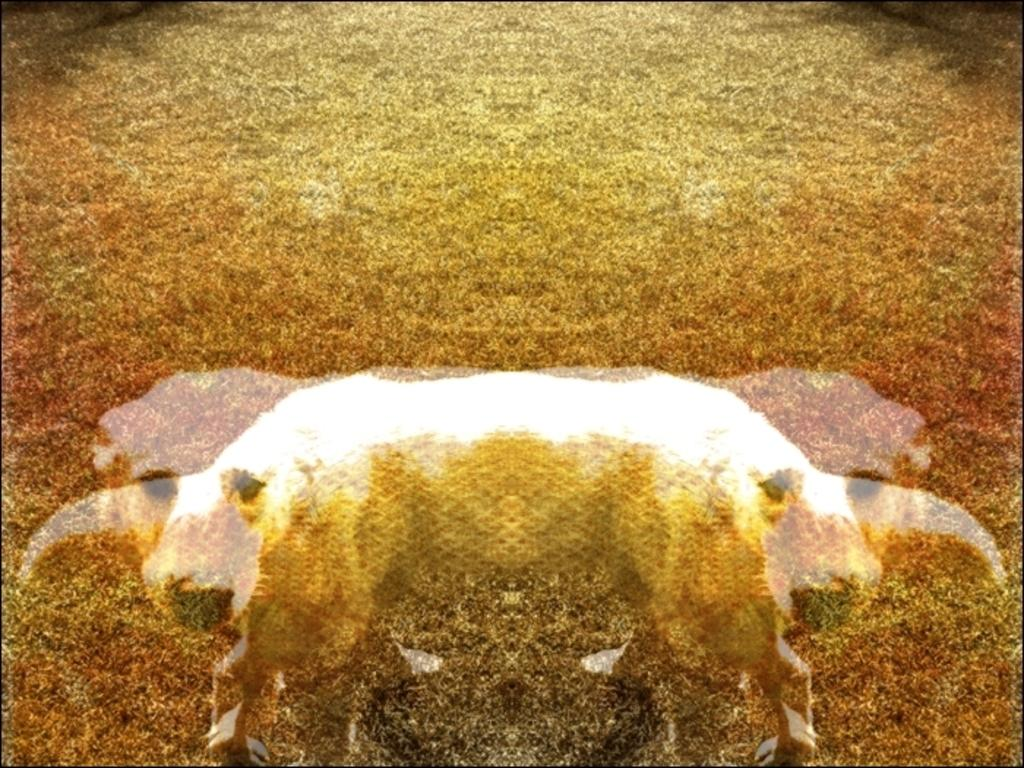What type of animal is in the image? There is a white dog in the image. What is the dog doing in the image? The dog is standing on the ground. What type of terrain is visible in the image? Grass is visible at the top of the image. What type of operation is the dog undergoing in the image? There is no indication of an operation in the image; the dog is simply standing on the ground. 